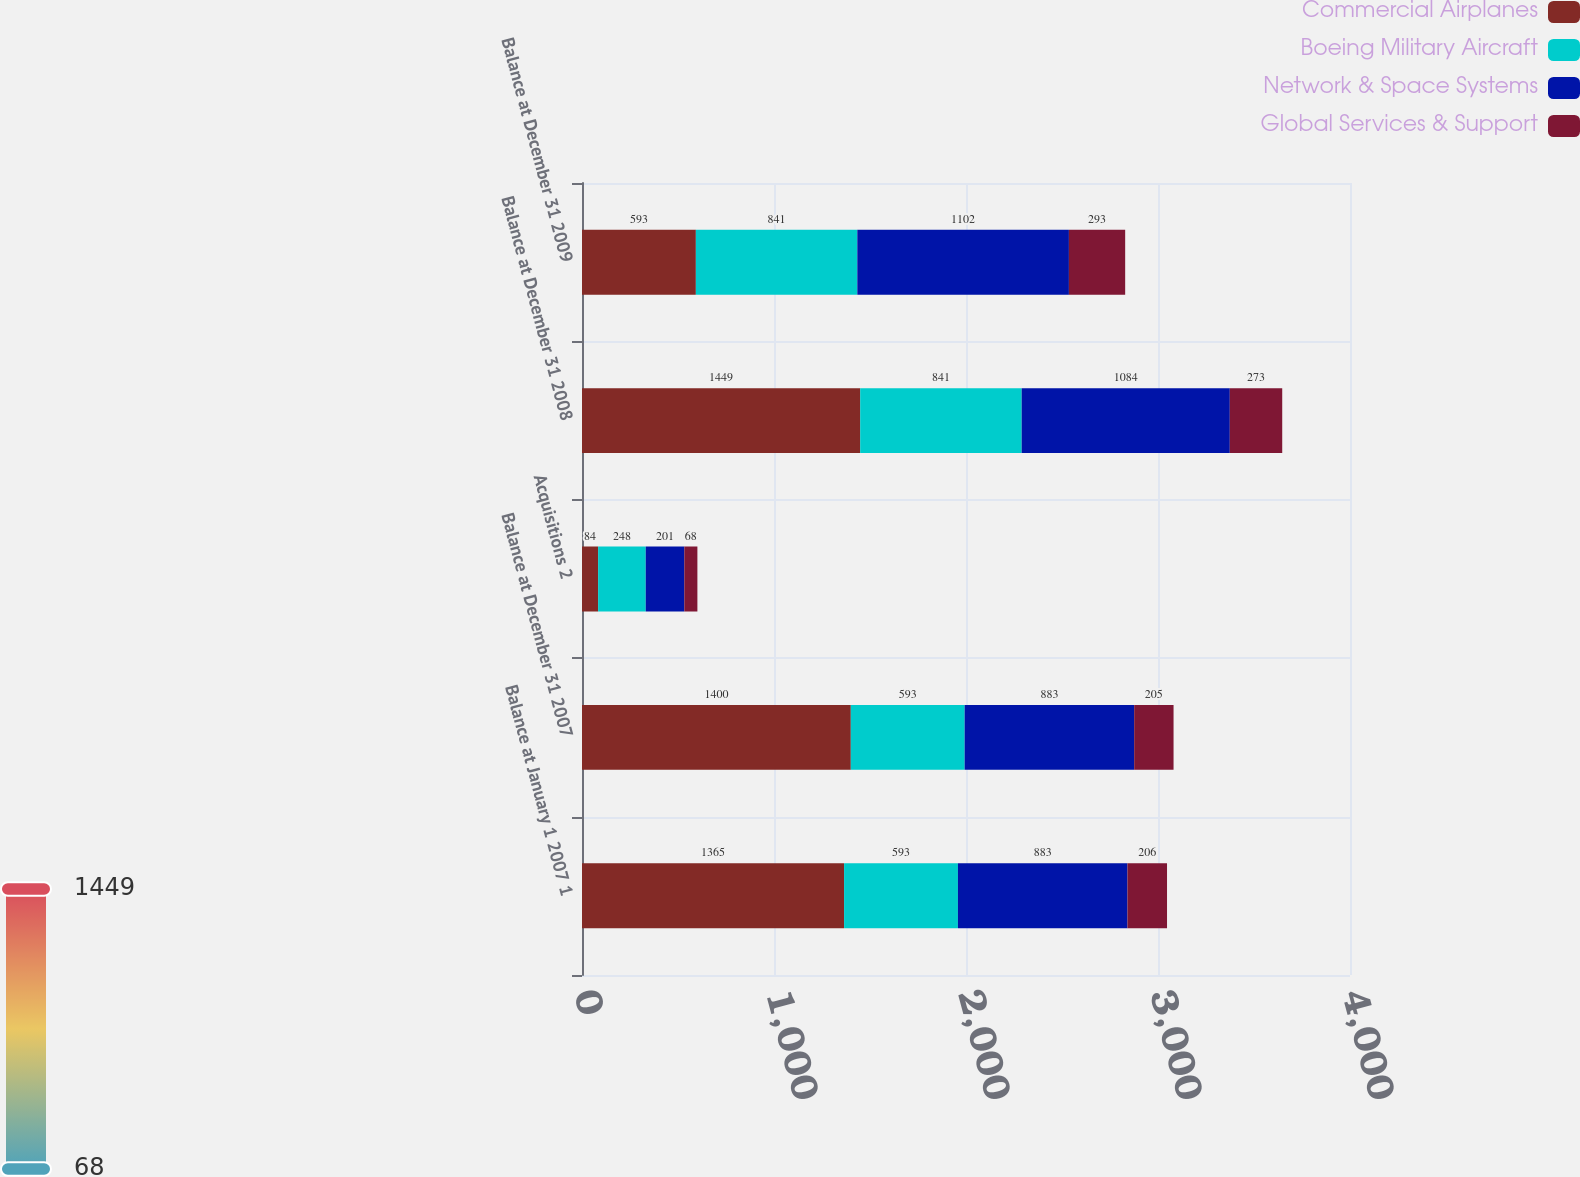Convert chart to OTSL. <chart><loc_0><loc_0><loc_500><loc_500><stacked_bar_chart><ecel><fcel>Balance at January 1 2007 1<fcel>Balance at December 31 2007<fcel>Acquisitions 2<fcel>Balance at December 31 2008<fcel>Balance at December 31 2009<nl><fcel>Commercial Airplanes<fcel>1365<fcel>1400<fcel>84<fcel>1449<fcel>593<nl><fcel>Boeing Military Aircraft<fcel>593<fcel>593<fcel>248<fcel>841<fcel>841<nl><fcel>Network & Space Systems<fcel>883<fcel>883<fcel>201<fcel>1084<fcel>1102<nl><fcel>Global Services & Support<fcel>206<fcel>205<fcel>68<fcel>273<fcel>293<nl></chart> 